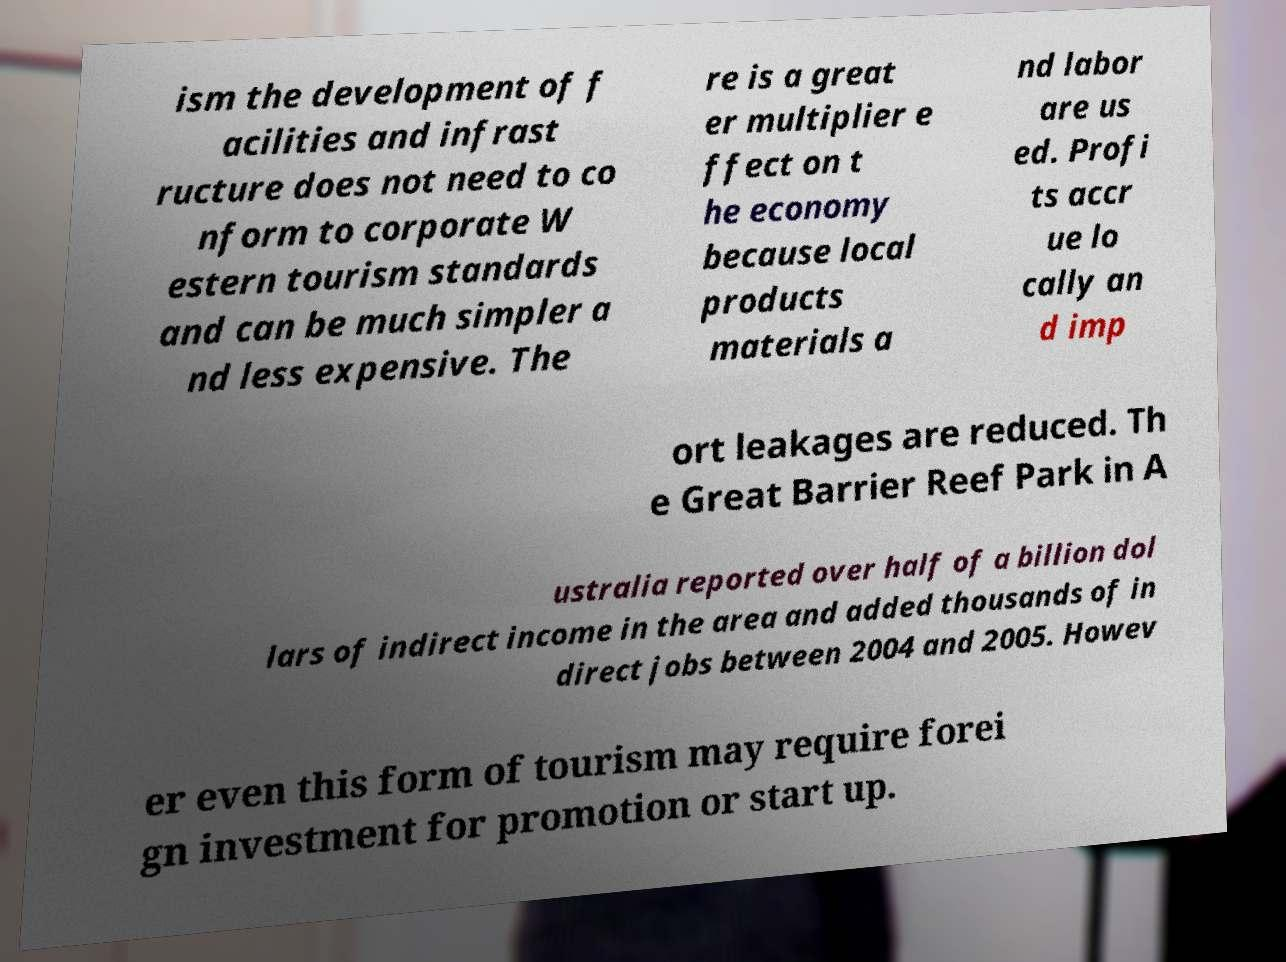Could you assist in decoding the text presented in this image and type it out clearly? ism the development of f acilities and infrast ructure does not need to co nform to corporate W estern tourism standards and can be much simpler a nd less expensive. The re is a great er multiplier e ffect on t he economy because local products materials a nd labor are us ed. Profi ts accr ue lo cally an d imp ort leakages are reduced. Th e Great Barrier Reef Park in A ustralia reported over half of a billion dol lars of indirect income in the area and added thousands of in direct jobs between 2004 and 2005. Howev er even this form of tourism may require forei gn investment for promotion or start up. 